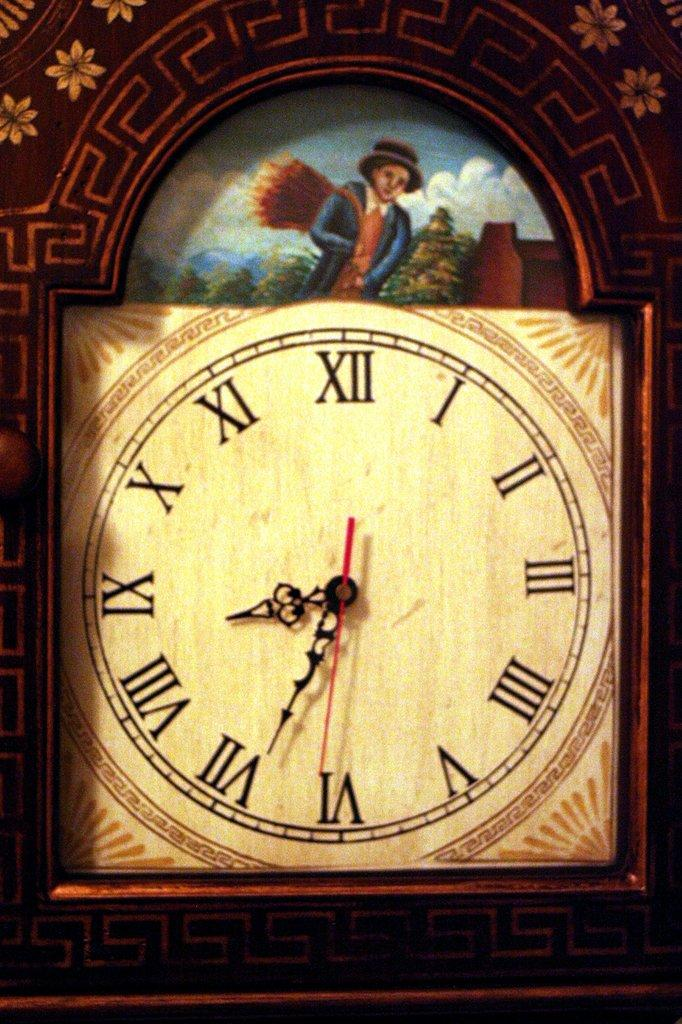<image>
Provide a brief description of the given image. Roman numeral clock with a picture of a boy 